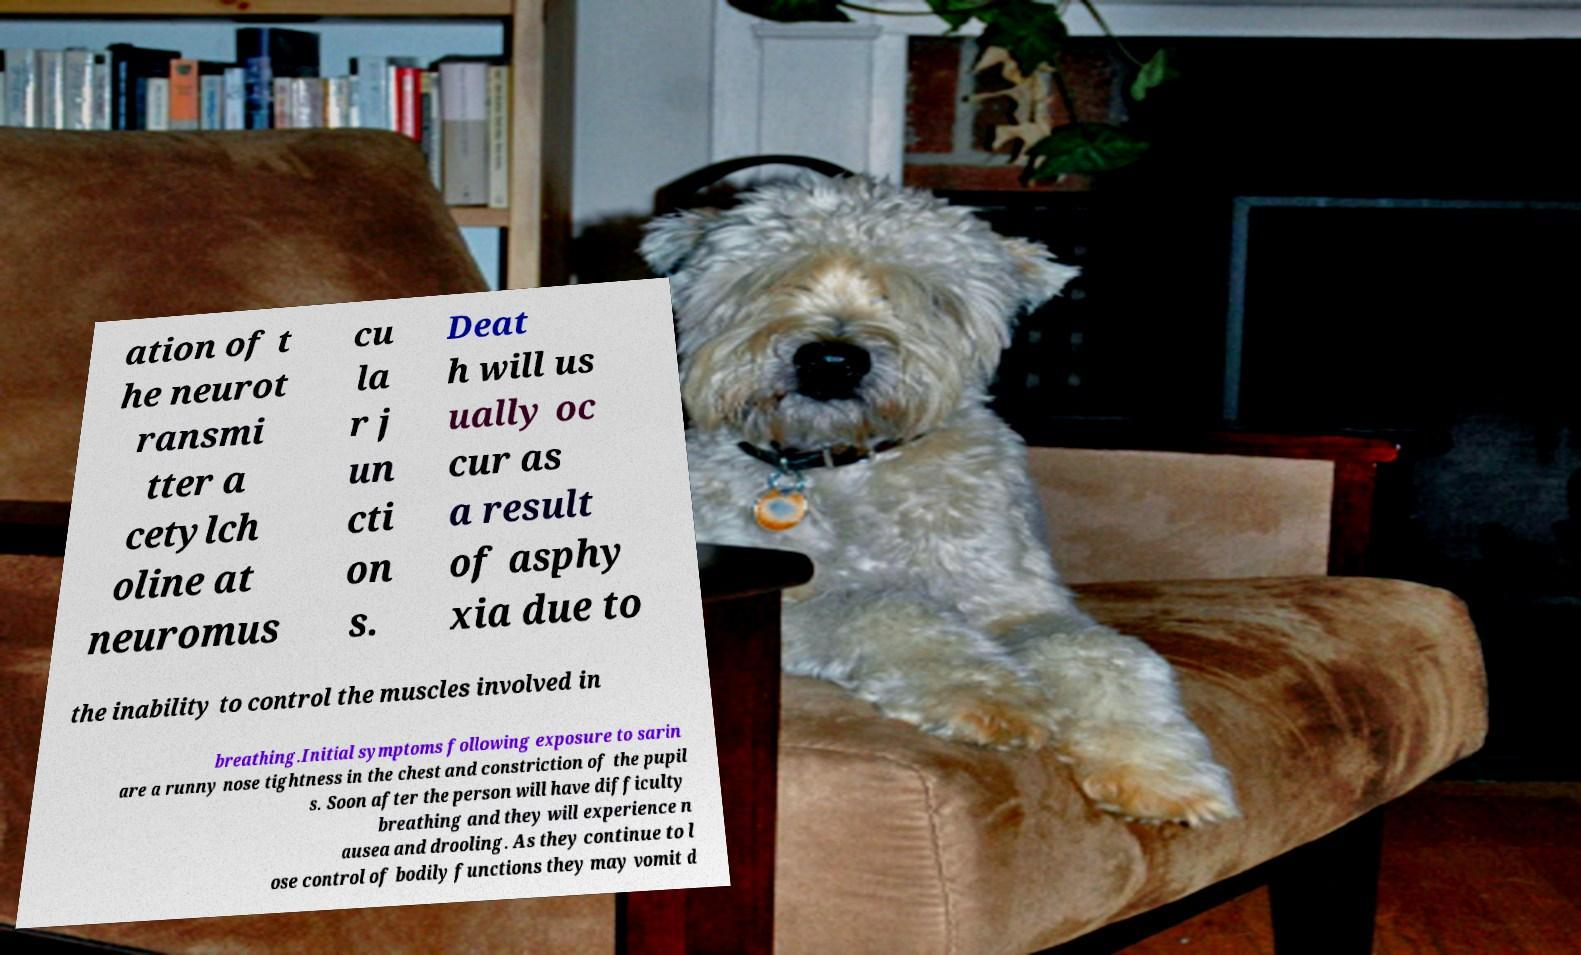Please read and relay the text visible in this image. What does it say? ation of t he neurot ransmi tter a cetylch oline at neuromus cu la r j un cti on s. Deat h will us ually oc cur as a result of asphy xia due to the inability to control the muscles involved in breathing.Initial symptoms following exposure to sarin are a runny nose tightness in the chest and constriction of the pupil s. Soon after the person will have difficulty breathing and they will experience n ausea and drooling. As they continue to l ose control of bodily functions they may vomit d 